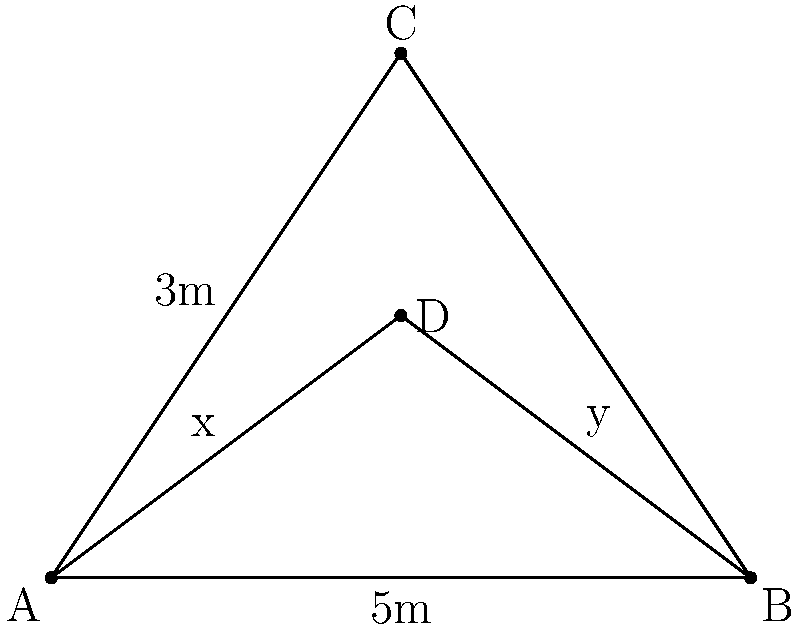In a film set, a lighting technician needs to determine the optimal distance to place a key light from an actor. The technician knows that the actor is 5m away from the camera and 3m tall. If the light needs to be placed at half the actor's height, what is the distance (y) from the camera to the light? Let's approach this step-by-step using similar triangles:

1) In the diagram, triangle ABC represents the larger triangle formed by the camera (A), the top of the actor (C), and the base of the actor (B).

2) Triangle ABD represents the smaller, similar triangle formed by the camera (A), the light position (D), and the base of the actor (B).

3) We know that:
   - AB = 5m (distance from camera to actor)
   - AC = 3m (height of the actor)
   - AD = x (distance from camera to light)
   - DB = y (what we're trying to find)

4) The light needs to be placed at half the actor's height, so:
   $AD : AC = 1 : 2$
   $x : 3 = 1 : 2$
   $x = 1.5m$

5) Now we can use the similarity of triangles ABD and ABC:
   $\frac{AD}{AC} = \frac{AB}{AB+DB}$

6) Substituting the known values:
   $\frac{1.5}{3} = \frac{5}{5+y}$

7) Cross multiply:
   $1.5(5+y) = 3(5)$
   $7.5 + 1.5y = 15$

8) Solve for y:
   $1.5y = 7.5$
   $y = 5m$

Therefore, the light should be placed 5m away from the camera.
Answer: 5m 